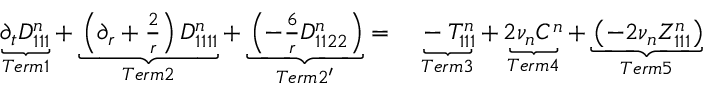Convert formula to latex. <formula><loc_0><loc_0><loc_500><loc_500>\begin{array} { r l } { \underbrace { \partial _ { t } D _ { 1 1 1 } ^ { n } } _ { T e r m 1 } + \underbrace { \left ( \partial _ { r } + \frac { 2 } { r } \right ) D _ { 1 1 1 1 } ^ { n } } _ { T e r m 2 } + \underbrace { \left ( - \frac { 6 } { r } D _ { 1 1 2 2 } ^ { n } \right ) } _ { T e r m 2 ^ { \prime } } = } & \underbrace { - T _ { 1 1 1 } ^ { n } } _ { T e r m 3 } + \underbrace { 2 \nu _ { n } C ^ { n } } _ { T e r m 4 } + \underbrace { \left ( - 2 \nu _ { n } Z _ { 1 1 1 } ^ { n } \right ) } _ { T e r m 5 } } \end{array}</formula> 